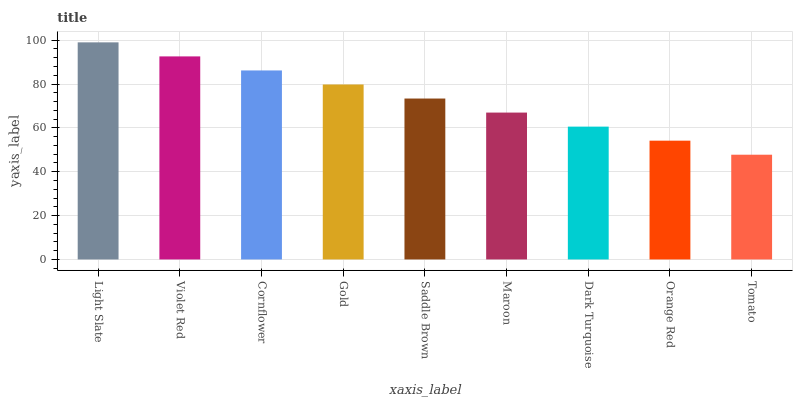Is Violet Red the minimum?
Answer yes or no. No. Is Violet Red the maximum?
Answer yes or no. No. Is Light Slate greater than Violet Red?
Answer yes or no. Yes. Is Violet Red less than Light Slate?
Answer yes or no. Yes. Is Violet Red greater than Light Slate?
Answer yes or no. No. Is Light Slate less than Violet Red?
Answer yes or no. No. Is Saddle Brown the high median?
Answer yes or no. Yes. Is Saddle Brown the low median?
Answer yes or no. Yes. Is Maroon the high median?
Answer yes or no. No. Is Maroon the low median?
Answer yes or no. No. 